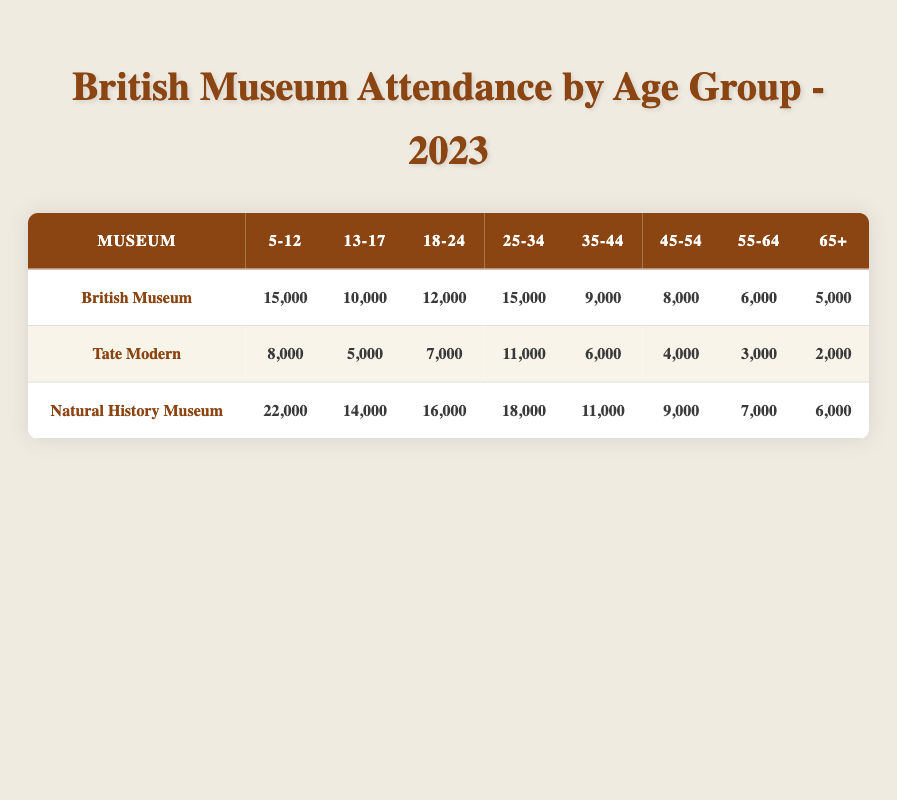What is the total attendance for the British Museum? To find the total attendance for the British Museum, we need to sum the attendance counts for all age groups listed for this museum. The counts are 15,000 (5-12) + 10,000 (13-17) + 12,000 (18-24) + 15,000 (25-34) + 9,000 (35-44) + 8,000 (45-54) + 6,000 (55-64) + 5,000 (65+). Adding these yields a total of 15,000 + 10,000 + 12,000 + 15,000 + 9,000 + 8,000 + 6,000 + 5,000 = 70,000.
Answer: 70,000 Which age group had the highest attendance at the Natural History Museum? By examining the attendance counts for each age group at the Natural History Museum, we see that the highest count is for the age group 5-12 with 22,000 attendees, compared to other age groups: 14,000 (13-17), 16,000 (18-24), 18,000 (25-34), 11,000 (35-44), 9,000 (45-54), 7,000 (55-64), and 6,000 (65+). Therefore, 5-12 is the age group with the highest attendance.
Answer: 5-12 What is the average attendance for the 25-34 age group across all museums? To calculate the average attendance for the 25-34 age group, we first find the total attendance across the three museums: 15,000 (British Museum) + 11,000 (Tate Modern) + 18,000 (Natural History Museum) = 44,000. There are three museums, so we divide the total by 3: 44,000 / 3 = 14,666.67. Rounding to the nearest unit, the average is approximately 14,667.
Answer: 14,667 Is the attendance for the Tate Modern in the age group 65+ less than that of the British Museum in the same age group? For the Tate Modern, the attendance in the 65+ age group is 2,000. For the British Museum, the attendance in the 65+ age group is 5,000. Since 2,000 is indeed less than 5,000, the answer is yes.
Answer: Yes How does the attendance of the 18-24 age group at the Natural History Museum compare to the same age group at the Tate Modern? The attendance for the 18-24 age group at the Natural History Museum is 16,000, while at the Tate Modern it is 7,000. To compare, we see that 16,000 is greater than 7,000. This indicates that more people in this age group visited the Natural History Museum compared to the Tate Modern.
Answer: Greater What is the total attendance for all museums in the age group 13-17? We will add the attendance counts for the 13-17 age group from each museum: 10,000 (British Museum) + 5,000 (Tate Modern) + 14,000 (Natural History Museum) = 29,000. This gives us the total attendance for the 13-17 age group across all museums.
Answer: 29,000 Which age group had the lowest attendance at the Tate Modern? The attendance counts for each age group at the Tate Modern are 8,000 (5-12), 5,000 (13-17), 7,000 (18-24), 11,000 (25-34), 6,000 (35-44), 4,000 (45-54), 3,000 (55-64), and 2,000 (65+). The lowest count is 2,000 in the 65+ age group, making it the age group with the least attendance at this museum.
Answer: 65+ What is the difference in attendance between the 55-64 age group at the British Museum and the Natural History Museum? For the British Museum, the attendance in the 55-64 age group is 6,000, while at the Natural History Museum, it is 7,000. To find the difference, we subtract the British Museum's count from that of the Natural History Museum: 7,000 - 6,000 = 1,000. This shows that the Natural History Museum had 1,000 more attendees in this age group.
Answer: 1,000 